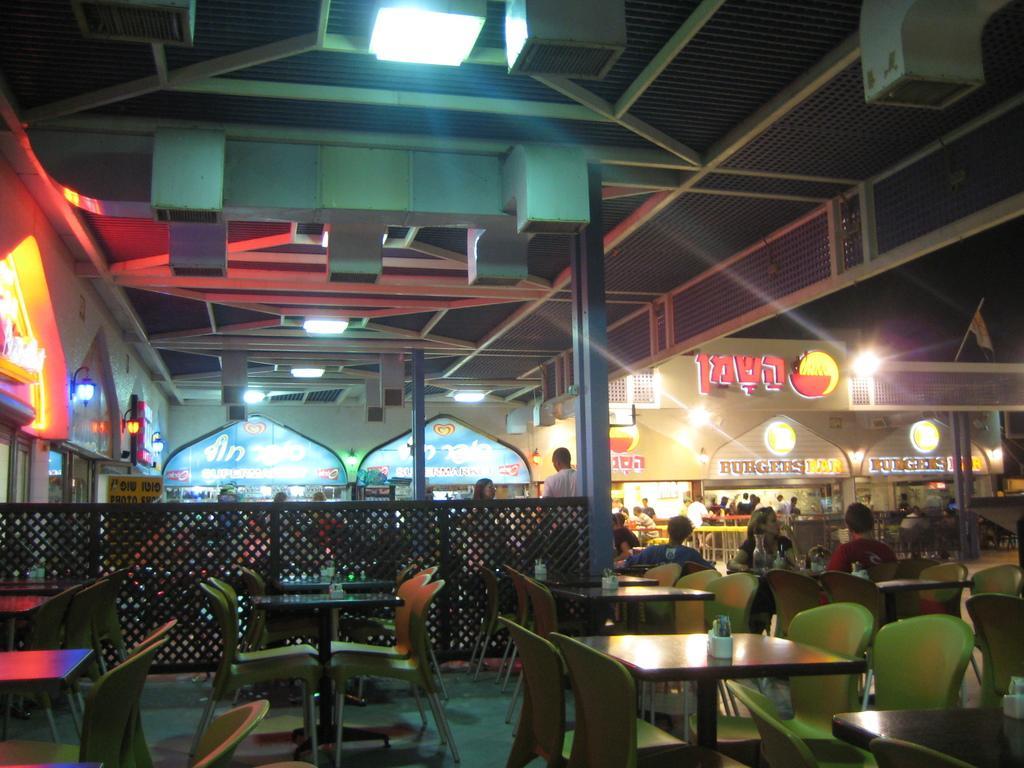Could you give a brief overview of what you see in this image? In the foreground I can see tables, chairs, fence, group of people are sitting on the chairs, pillars, metal rods, boards and few are standing on the floor. In the background I can see a rooftop, lights, text and shops. This image is taken may be in a hotel. 